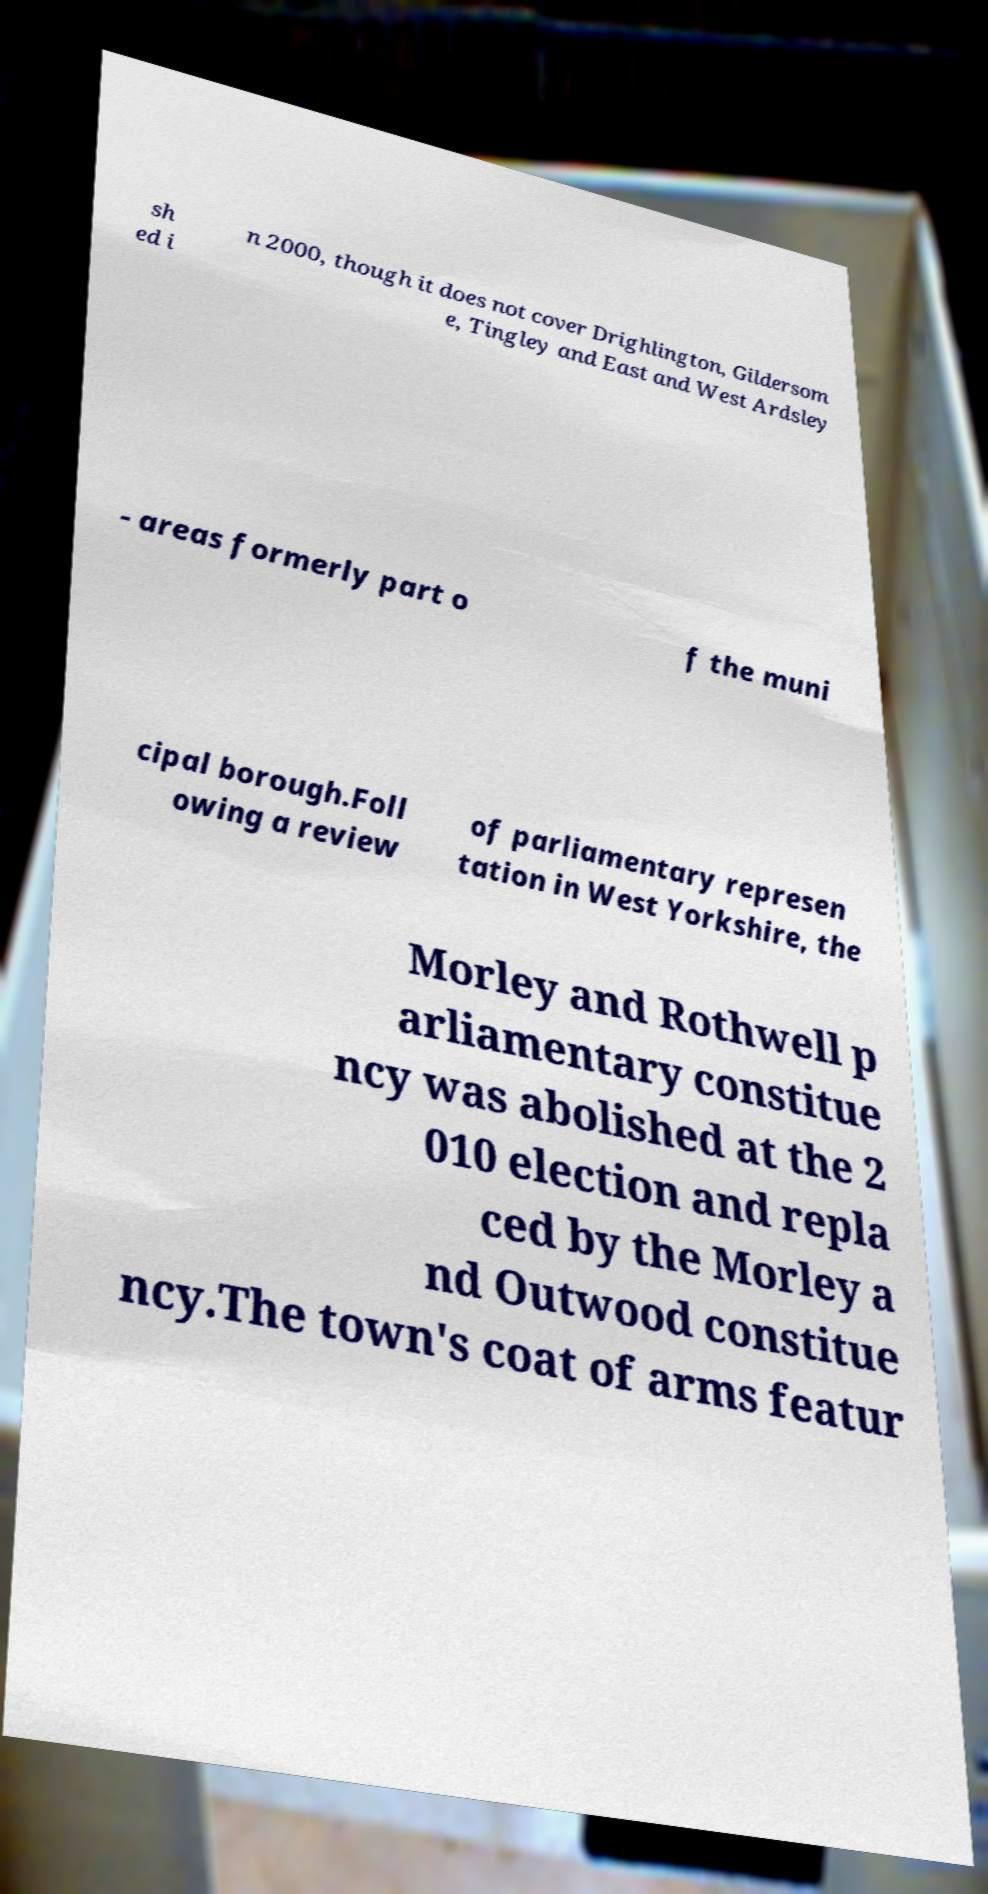Can you accurately transcribe the text from the provided image for me? sh ed i n 2000, though it does not cover Drighlington, Gildersom e, Tingley and East and West Ardsley - areas formerly part o f the muni cipal borough.Foll owing a review of parliamentary represen tation in West Yorkshire, the Morley and Rothwell p arliamentary constitue ncy was abolished at the 2 010 election and repla ced by the Morley a nd Outwood constitue ncy.The town's coat of arms featur 